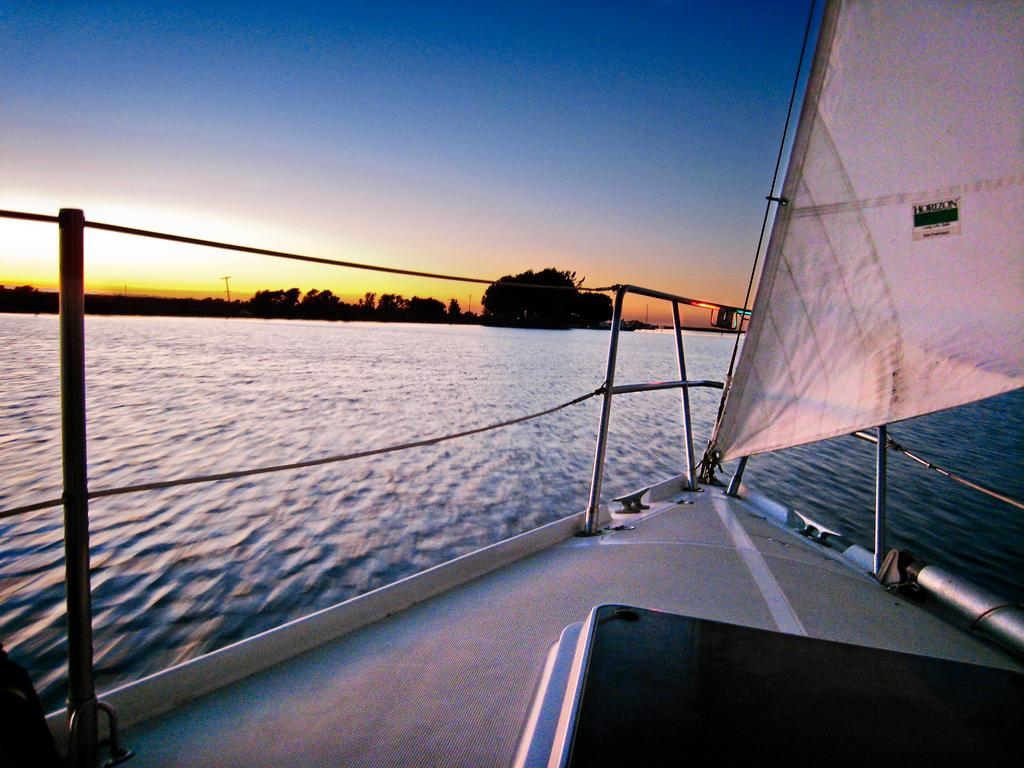What is the main subject of the image? The main subject of the image is a boat. Where is the boat located? The boat is on the water. What can be seen in the background of the image? There are trees and the sky visible in the background of the image. How many beans are in the jar next to the boat in the image? There is no jar or beans present in the image. Who are the friends sitting in the boat in the image? There are no people or friends visible in the image; only the boat is present. 